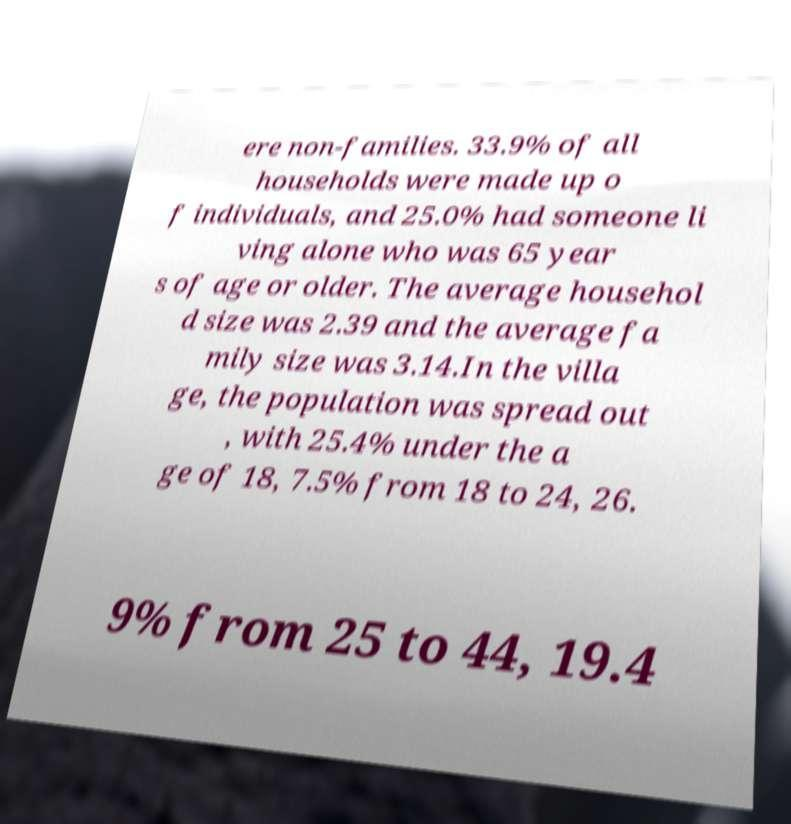Could you extract and type out the text from this image? ere non-families. 33.9% of all households were made up o f individuals, and 25.0% had someone li ving alone who was 65 year s of age or older. The average househol d size was 2.39 and the average fa mily size was 3.14.In the villa ge, the population was spread out , with 25.4% under the a ge of 18, 7.5% from 18 to 24, 26. 9% from 25 to 44, 19.4 